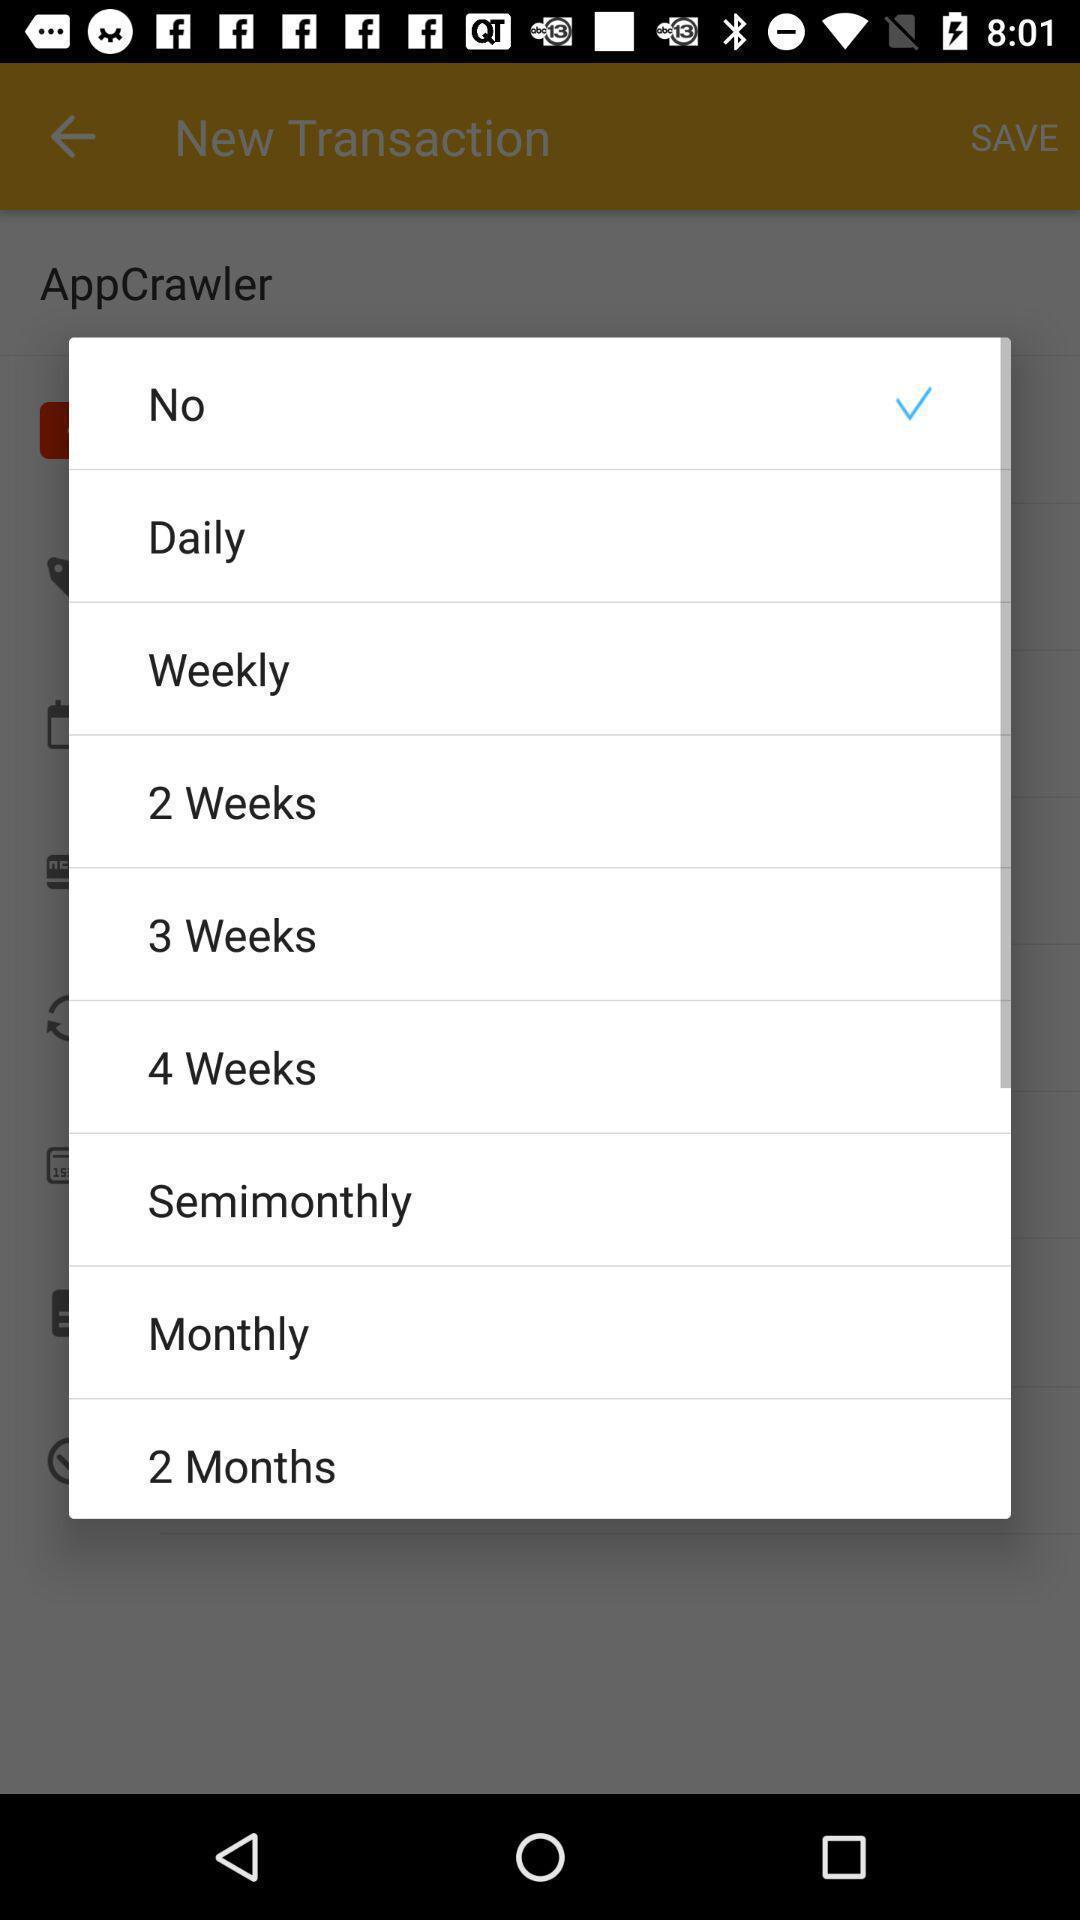Give me a summary of this screen capture. Pop-up displaying various options to select. 